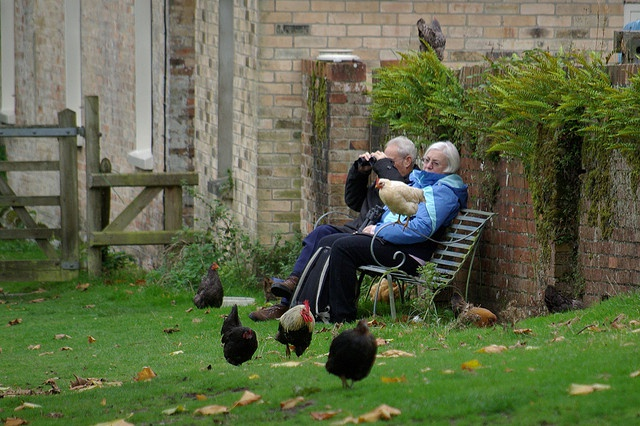Describe the objects in this image and their specific colors. I can see people in gray, black, darkgray, blue, and navy tones, bench in gray, black, darkgreen, and darkgray tones, people in gray, black, navy, and darkgray tones, bird in gray, black, and darkgreen tones, and bird in gray, black, darkgreen, and green tones in this image. 